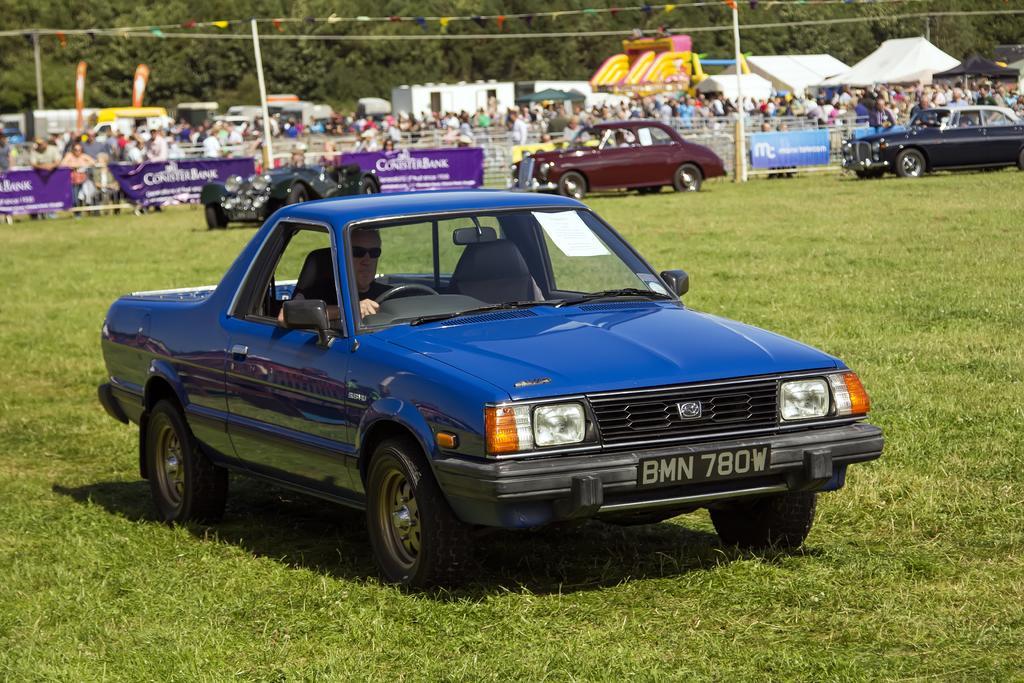In one or two sentences, can you explain what this image depicts? There are four cars on the ground. This is grass and there are banners. In the background we can see persons, fence, poles, flags, tents, and trees. 